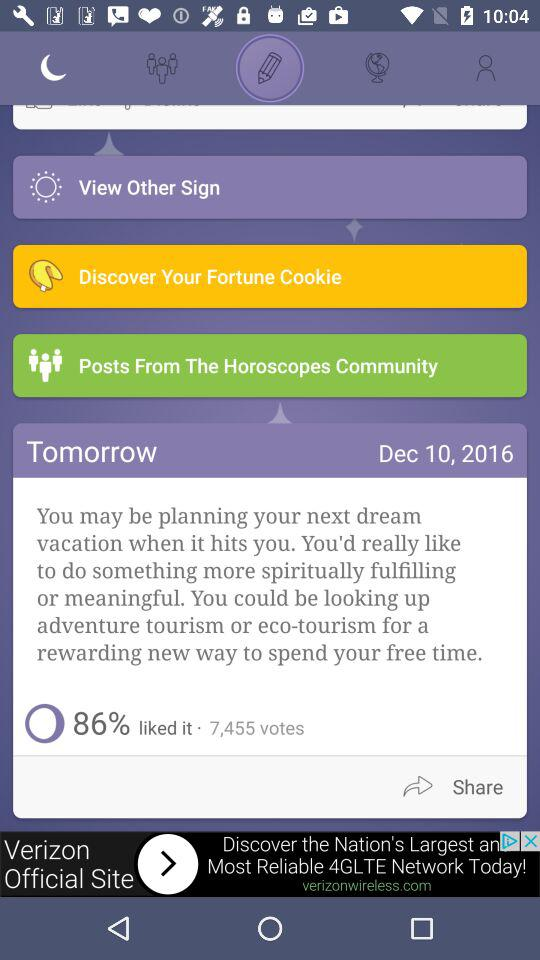How many days in the future is the horoscope for?
Answer the question using a single word or phrase. 1 